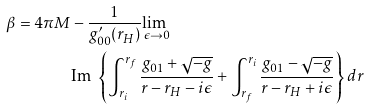Convert formula to latex. <formula><loc_0><loc_0><loc_500><loc_500>\beta = 4 \pi M & - \frac { 1 } { g ^ { \prime } _ { 0 0 } ( r _ { H } ) } \underset { \epsilon \rightarrow 0 } { \text {lim } } \\ & \text {Im } \left \{ \int _ { r _ { i } } ^ { r _ { f } } \frac { g _ { 0 1 } + \sqrt { - g } } { r - r _ { H } - i \epsilon } + \int _ { r _ { f } } ^ { r _ { i } } \frac { g _ { 0 1 } - \sqrt { - g } } { r - r _ { H } + i \epsilon } \right \} d r</formula> 